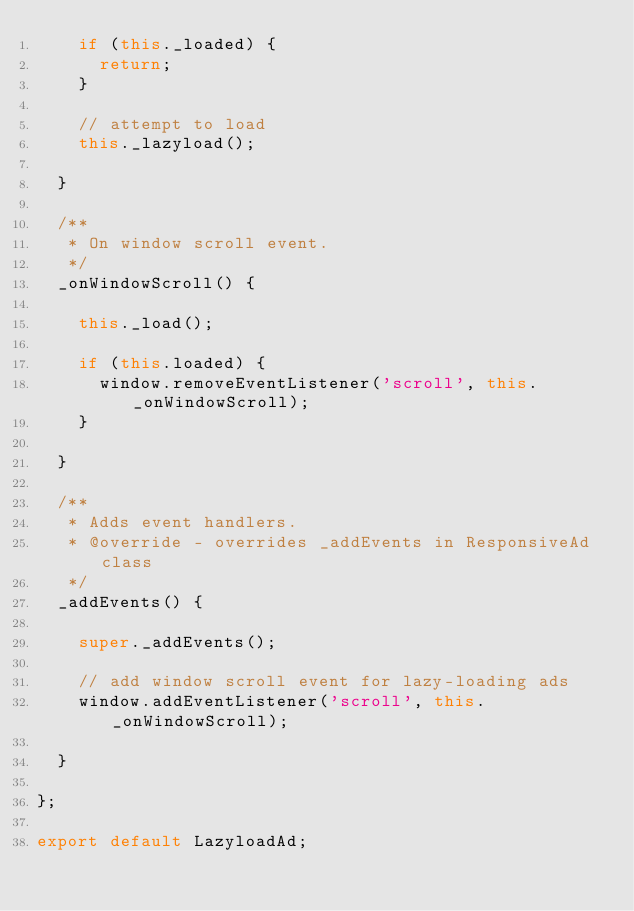<code> <loc_0><loc_0><loc_500><loc_500><_JavaScript_>    if (this._loaded) {
      return;
    }

    // attempt to load
    this._lazyload();

  }

  /**
   * On window scroll event.
   */
  _onWindowScroll() {

    this._load();

    if (this.loaded) {
      window.removeEventListener('scroll', this._onWindowScroll);
    }

  }

  /**
   * Adds event handlers.
   * @override - overrides _addEvents in ResponsiveAd class
   */
  _addEvents() {

    super._addEvents();

    // add window scroll event for lazy-loading ads
    window.addEventListener('scroll', this._onWindowScroll);

  }

};

export default LazyloadAd;
</code> 